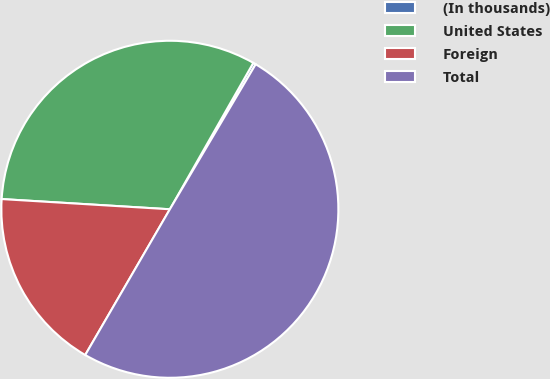<chart> <loc_0><loc_0><loc_500><loc_500><pie_chart><fcel>(In thousands)<fcel>United States<fcel>Foreign<fcel>Total<nl><fcel>0.26%<fcel>32.28%<fcel>17.59%<fcel>49.87%<nl></chart> 